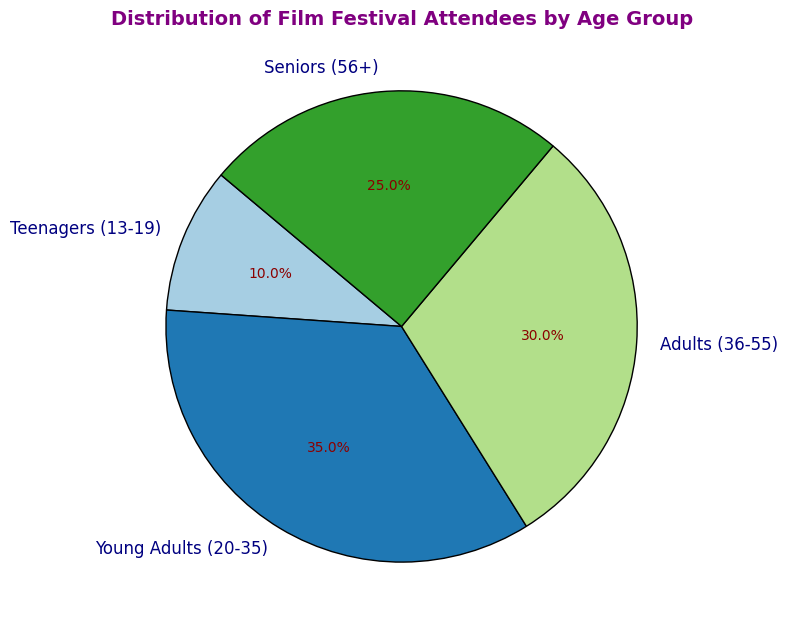What's the percentage of adults attending the festival compared to teenagers? The percentage of adults (36-55) attending the festival is 30% while teenagers (13-19) make up 10%. To compare: 30% (adults) - 10% (teenagers) = 20%. Adults attend the festival 20% more than teenagers.
Answer: 20% Which age group has the lowest attendance? By looking at the figure, we can see the smallest percentage share. Teenagers (13-19) have the smallest slice of the pie chart with 10%.
Answer: Teenagers (13-19) What's the sum of percentages for attendees aged 20-35 and 56+? Young Adults (20-35) make up 35% and Seniors (56+) make up 25%. Adding these percentages together: 35% + 25% = 60%.
Answer: 60% Which age group constitutes more than a quarter of the attendees? Checking the pie chart, we see that 35% for Young Adults (20-35) and 30% for Adults (36-55) are both more than 25%.
Answer: Young Adults (20-35) and Adults (36-55) Are there more Young Adults attending the festival than Adults and Seniors combined? Young Adults (20-35) make up 35%, while Adults (36-55) and Seniors (56+) together make up 30% + 25% = 55%. Thus, 35% < 55%.
Answer: No How does the percentage of Seniors compare to the percentage of Teenagers? Seniors (56+) make up 25% of the attendees, while Teenagers (13-19) make up 10%. Comparing these two percentages: 25% (Seniors) - 10% (Teenagers) = 15%. There are 15% more Seniors than Teenagers.
Answer: 15% more Seniors What is the average percentage of attendees across all age groups? Add the percentages: 10% (Teenagers) + 35% (Young Adults) + 30% (Adults) + 25% (Seniors) = 100%. Divide by the number of groups: 100% / 4 = 25%.
Answer: 25% Which age group’s section in the pie chart is colored in the fourth position (starting from the top right corner)? By identifying the sections in a clockwise manner starting from the top right corner, the sections are ordered as Teenagers (13-19), Young Adults (20-35), Adults (36-55), then Seniors (56+). The fourth segment is therefore Seniors (56+).
Answer: Seniors (56+) What is the difference between the percentage of Young Adults and Adults? Young Adults (20-35) make up 35% and Adults (36-55) make up 30%. The difference is calculated as: 35% - 30% = 5%.
Answer: 5% What fraction of the total attendees are either Young Adults or Adults? Young Adults (20-35) are 35% and Adults (36-55) are 30%. Combined, they make up: 35% + 30% = 65%. The fraction is therefore 65/100, which simplifies to 13/20.
Answer: 13/20 